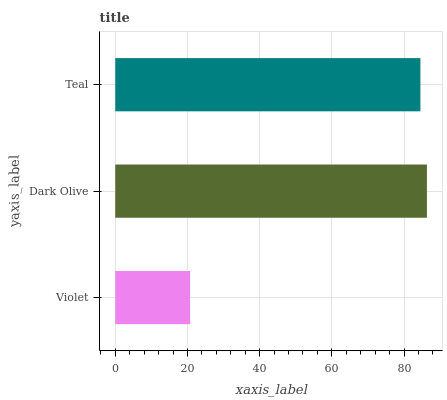Is Violet the minimum?
Answer yes or no. Yes. Is Dark Olive the maximum?
Answer yes or no. Yes. Is Teal the minimum?
Answer yes or no. No. Is Teal the maximum?
Answer yes or no. No. Is Dark Olive greater than Teal?
Answer yes or no. Yes. Is Teal less than Dark Olive?
Answer yes or no. Yes. Is Teal greater than Dark Olive?
Answer yes or no. No. Is Dark Olive less than Teal?
Answer yes or no. No. Is Teal the high median?
Answer yes or no. Yes. Is Teal the low median?
Answer yes or no. Yes. Is Dark Olive the high median?
Answer yes or no. No. Is Violet the low median?
Answer yes or no. No. 